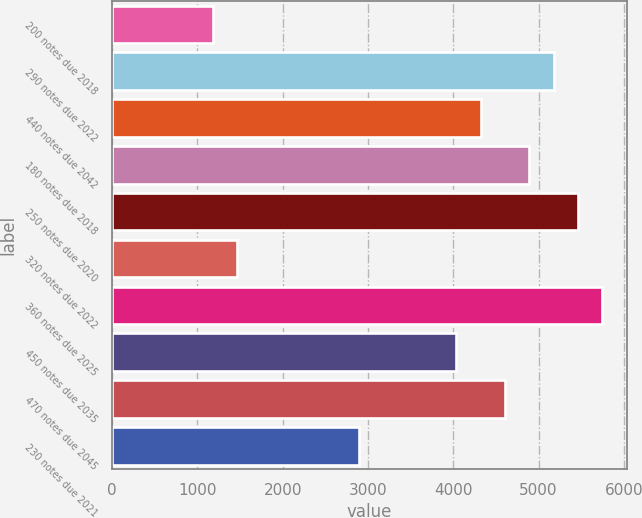Convert chart to OTSL. <chart><loc_0><loc_0><loc_500><loc_500><bar_chart><fcel>200 notes due 2018<fcel>290 notes due 2022<fcel>440 notes due 2042<fcel>180 notes due 2018<fcel>250 notes due 2020<fcel>320 notes due 2022<fcel>360 notes due 2025<fcel>450 notes due 2035<fcel>470 notes due 2045<fcel>230 notes due 2021<nl><fcel>1181.4<fcel>5177<fcel>4320.8<fcel>4891.6<fcel>5462.4<fcel>1466.8<fcel>5747.8<fcel>4035.4<fcel>4606.2<fcel>2893.8<nl></chart> 